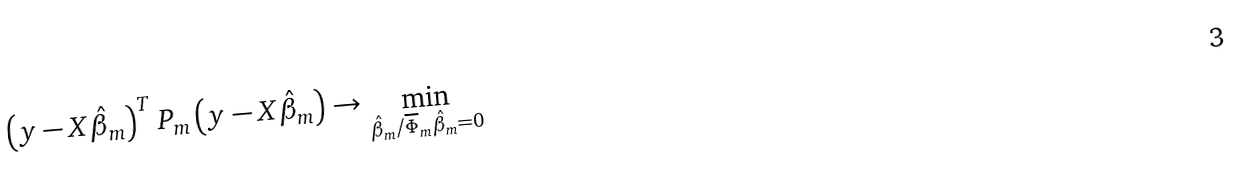Convert formula to latex. <formula><loc_0><loc_0><loc_500><loc_500>\left ( y - X \hat { \beta } _ { m } \right ) ^ { T } P _ { m } \left ( y - X \hat { \beta } _ { m } \right ) \rightarrow \min _ { \hat { \beta } _ { m } / \overline { \Phi } _ { m } \hat { \beta } _ { m } = 0 }</formula> 